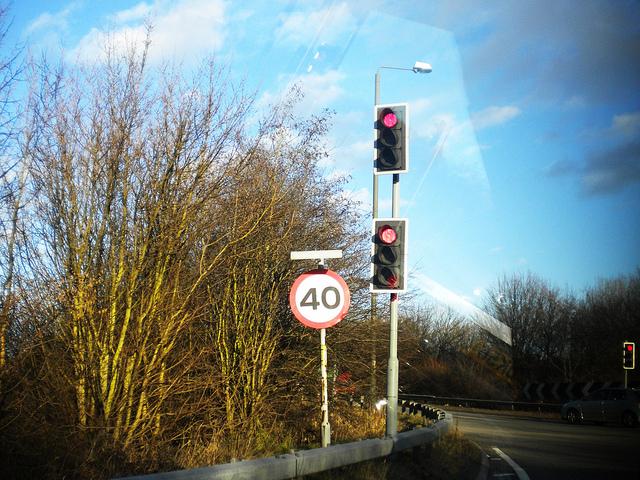What colors are the poles?
Short answer required. Gray. What number is on the sign?
Answer briefly. 40. Should they begin to drive?
Write a very short answer. No. Is that an American street sign?
Give a very brief answer. No. Can a driver turn left at this intersection?
Keep it brief. No. 